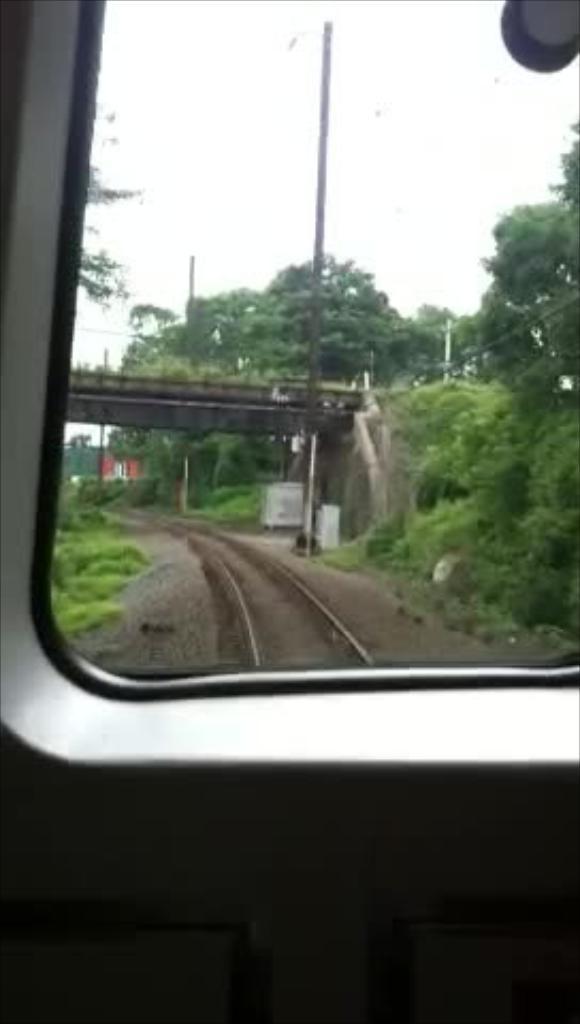Please provide a concise description of this image. The picture is taken from a window of a train, where we can see, trees, it seems like a bridge, railway track and the sky in the background. 